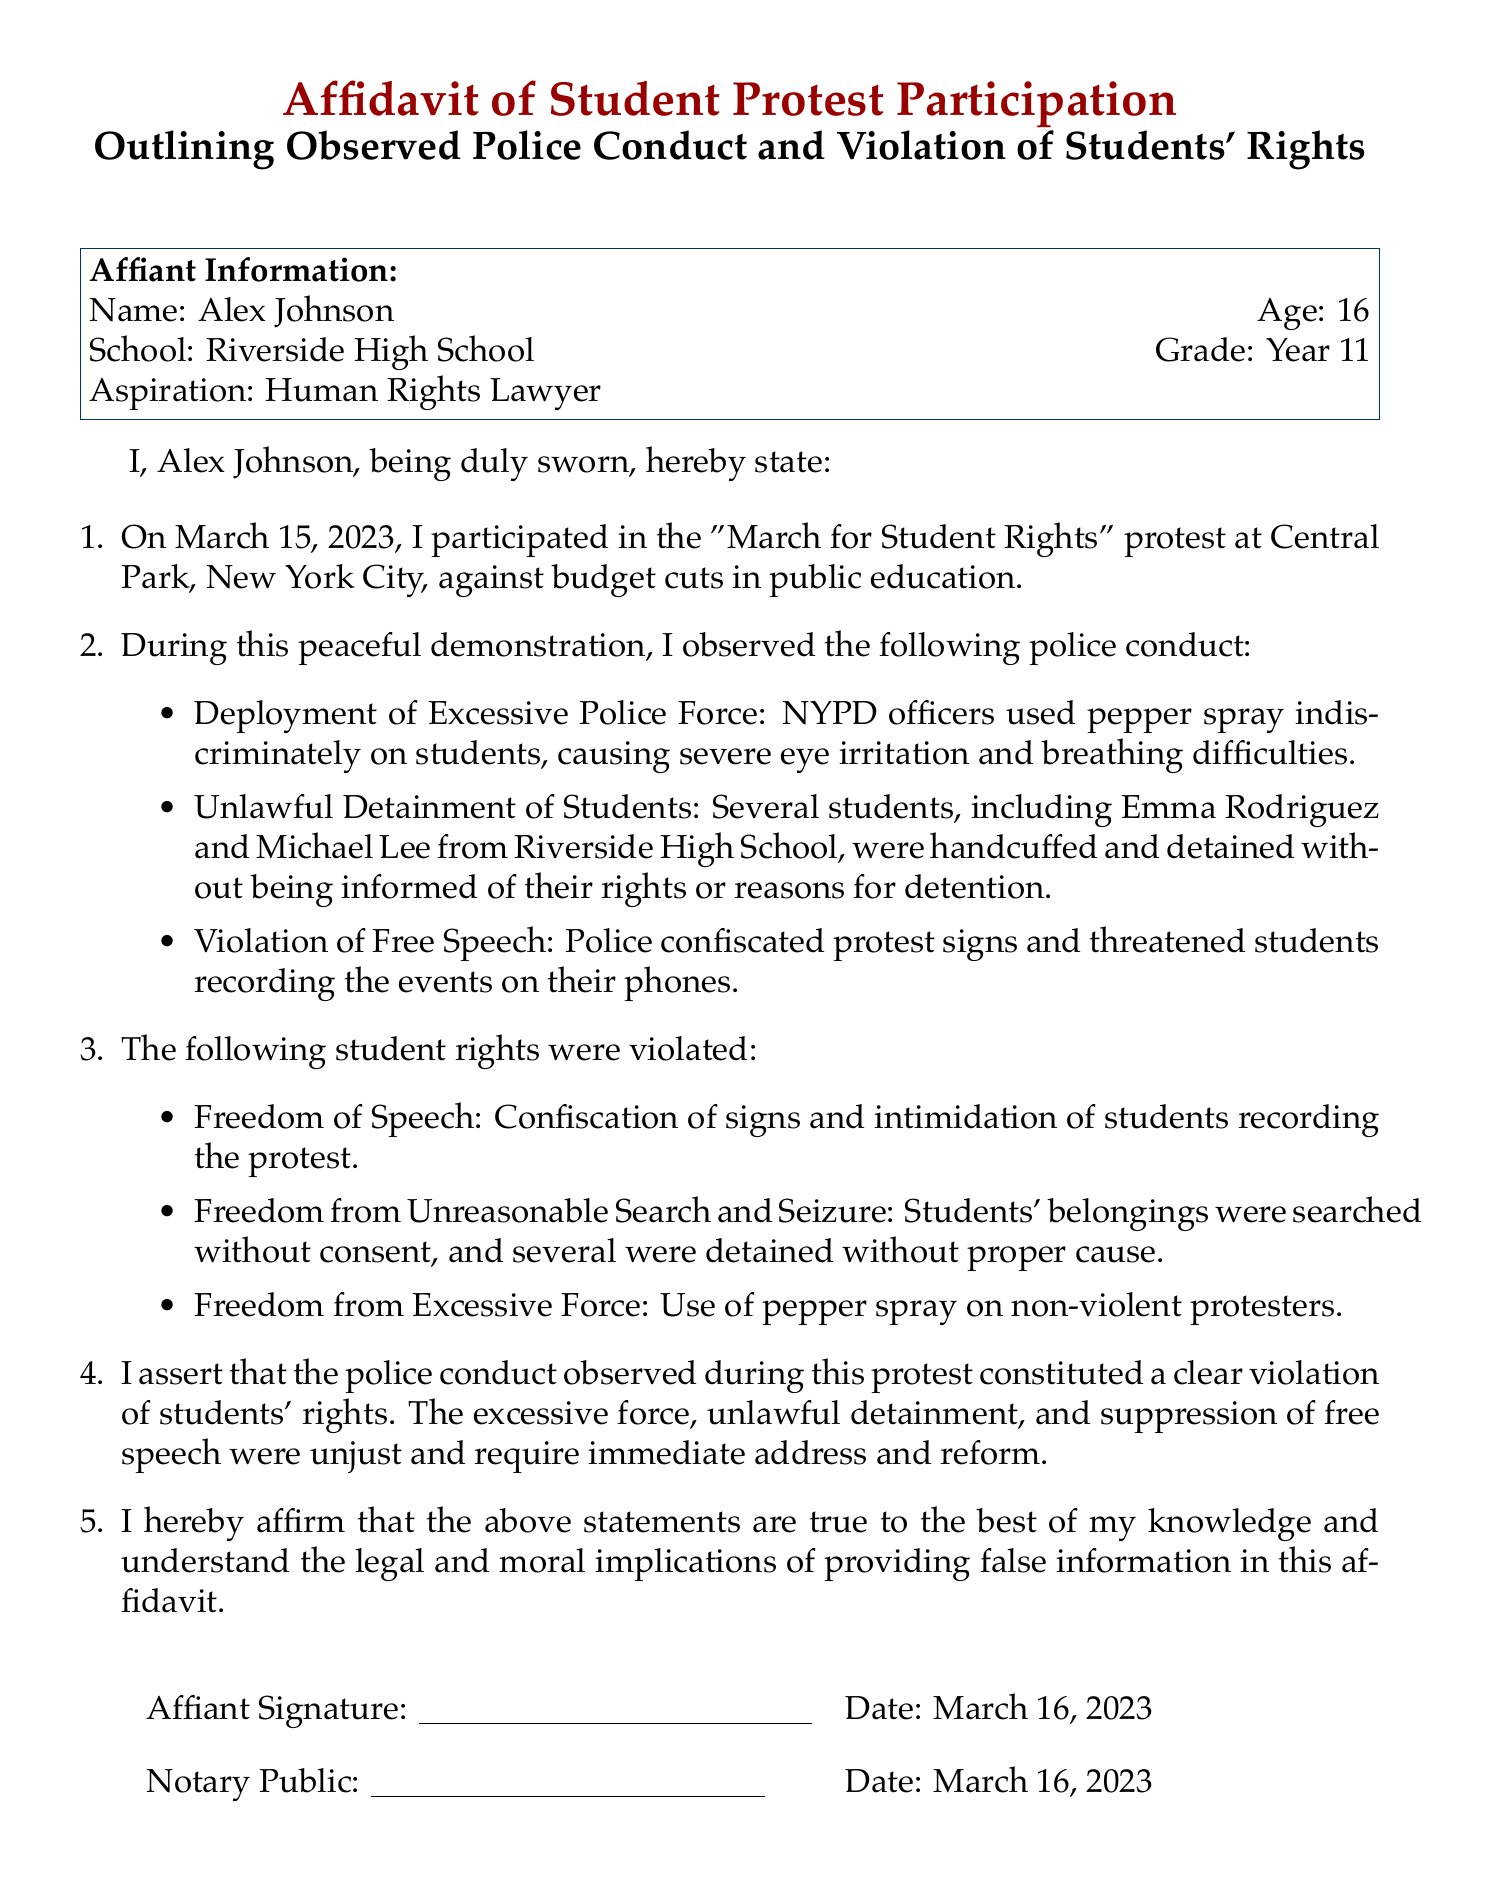What is the name of the affiant? The affiant's name is stated at the beginning of the document as the person making the affidavit.
Answer: Alex Johnson What is the date of the protest? The date of the protest is explicitly mentioned in the document as the day it occurred.
Answer: March 15, 2023 What school does the affiant attend? The affiant's school is identified within the personal information section of the document.
Answer: Riverside High School What action was taken by the police against students? This refers to specific conduct observed by the affiant during the protest that negatively impacted the students.
Answer: Used pepper spray What did the police threaten students about? This involves the specific intimidation tactic used to suppress student participation in the protest.
Answer: Recording the events Which right related to speech was violated? This refers to the specific constitutional right that was not upheld during the protest event.
Answer: Freedom of Speech Who were two students mentioned as unlawfully detained? This consists of names of individuals who experienced unlawful actions from the police during the protest.
Answer: Emma Rodriguez and Michael Lee What is the aspiration of the affiant? This question focuses on the future goal of the affiant as stated in the document.
Answer: Human Rights Lawyer What does the affiant assert about the police conduct? This seeks a specific conclusion drawn by the affiant regarding the nature of police actions observed.
Answer: Violation of students' rights 